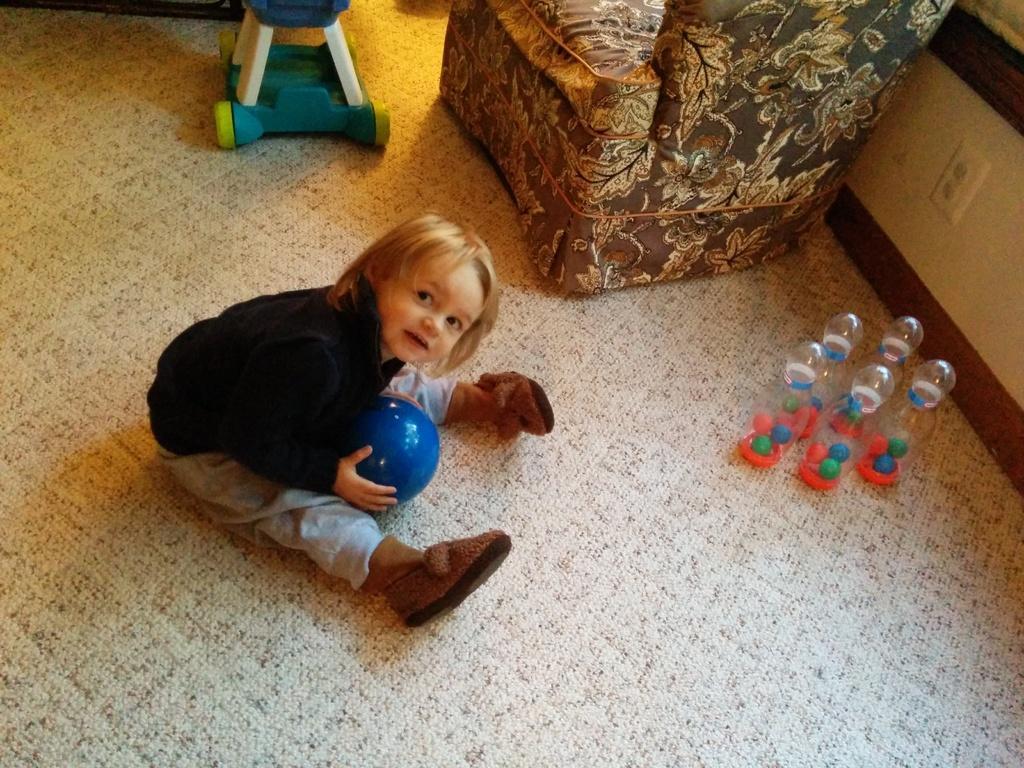Could you give a brief overview of what you see in this image? In this picture we can see a kid sitting and holding a ball, on the right side there are toys, we can see a chair here. 